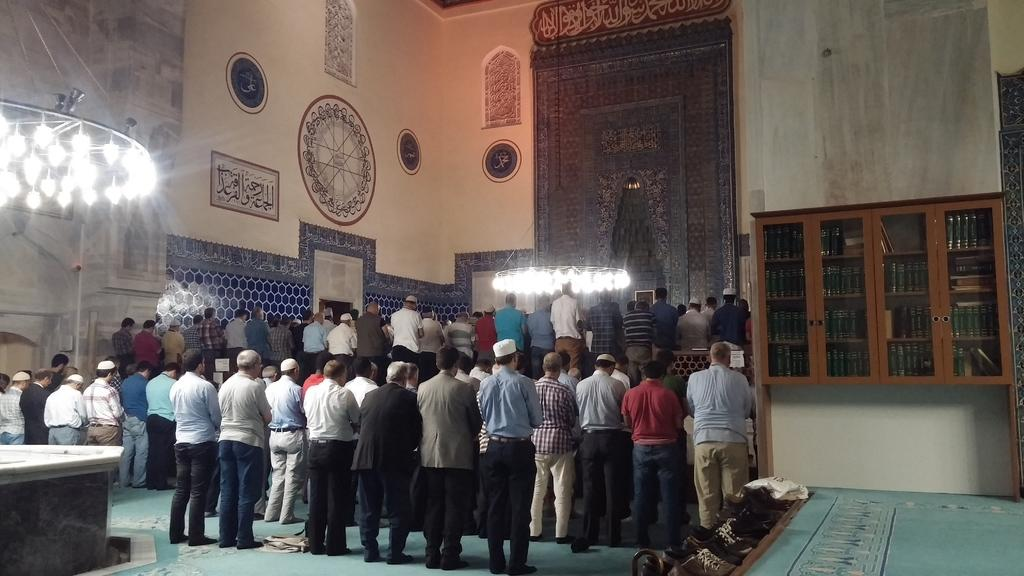What can be seen in the image involving people? There are people standing in the image. What type of furniture is present in the image? There is a cupboard with books in the image. What kind of decorations are on the wall in the image? There are paintings on the wall in the image. Where can footwear be found in the image? Footwear is visible on the side in the image. What type of rock can be seen in the image? There is no rock present in the image. Can you hear a bell ringing in the image? There is no bell present in the image, so it cannot be heard. 